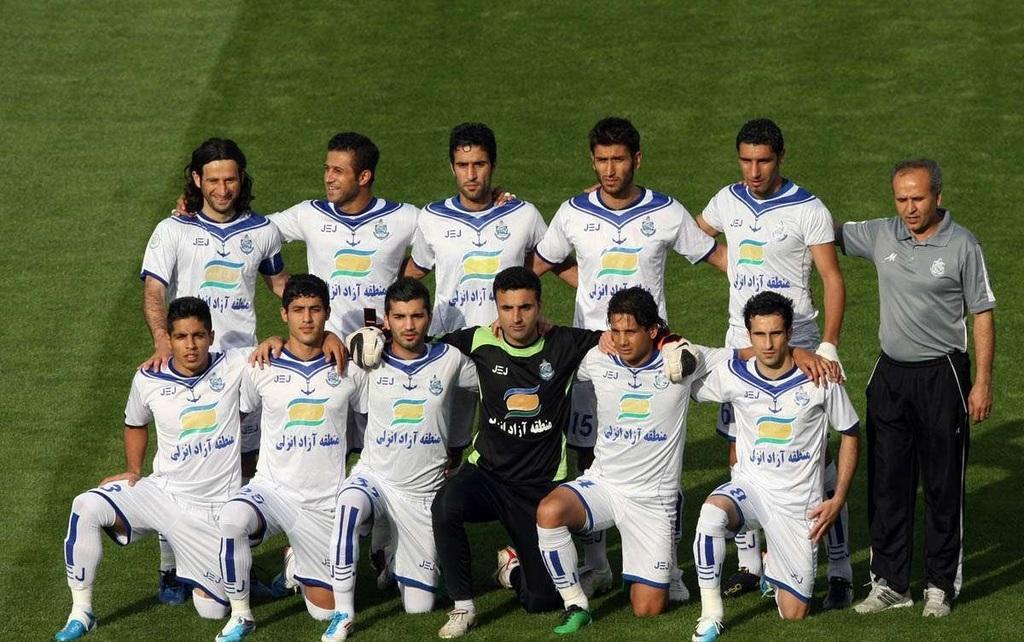Could you give a brief overview of what you see in this image? As we can see in the image there is grass and few people standing in the front. 